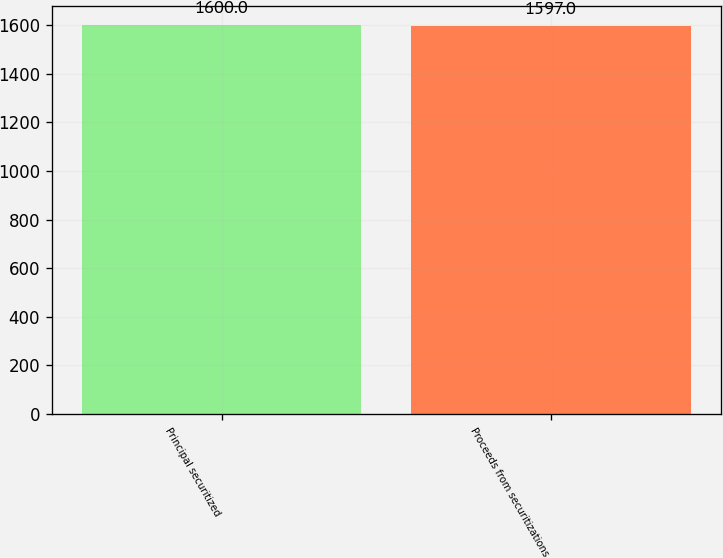Convert chart. <chart><loc_0><loc_0><loc_500><loc_500><bar_chart><fcel>Principal securitized<fcel>Proceeds from securitizations<nl><fcel>1600<fcel>1597<nl></chart> 